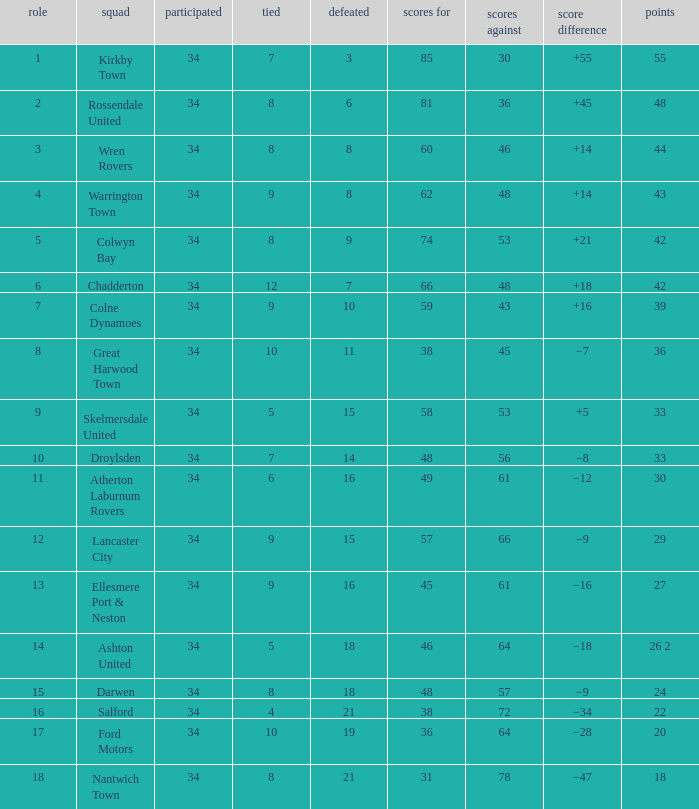What is the total number of positions when there are more than 48 goals against, 1 of 29 points are played, and less than 34 games have been played? 0.0. 